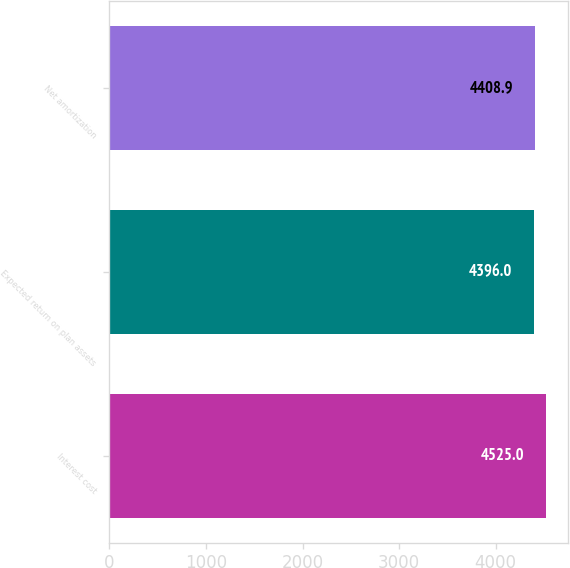Convert chart to OTSL. <chart><loc_0><loc_0><loc_500><loc_500><bar_chart><fcel>Interest cost<fcel>Expected return on plan assets<fcel>Net amortization<nl><fcel>4525<fcel>4396<fcel>4408.9<nl></chart> 